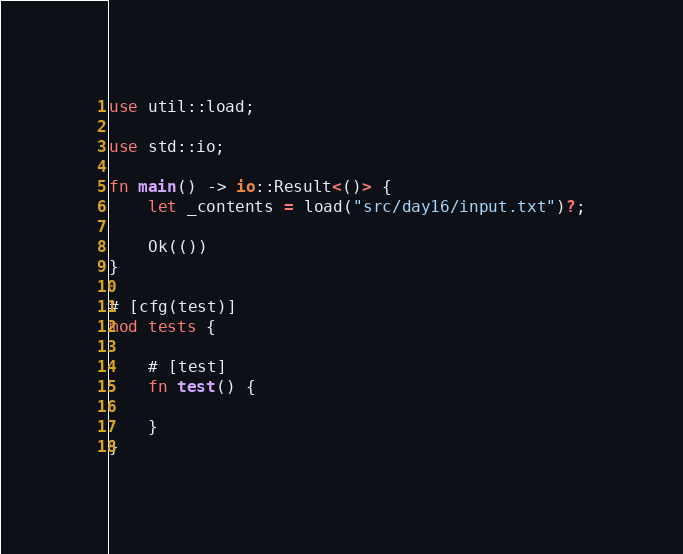<code> <loc_0><loc_0><loc_500><loc_500><_Rust_>
use util::load;

use std::io;

fn main() -> io::Result<()> {
    let _contents = load("src/day16/input.txt")?;

    Ok(())
}

# [cfg(test)]
mod tests {

    # [test]
    fn test() {

    }
}
</code> 